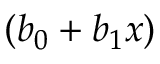Convert formula to latex. <formula><loc_0><loc_0><loc_500><loc_500>( b _ { 0 } + b _ { 1 } x )</formula> 